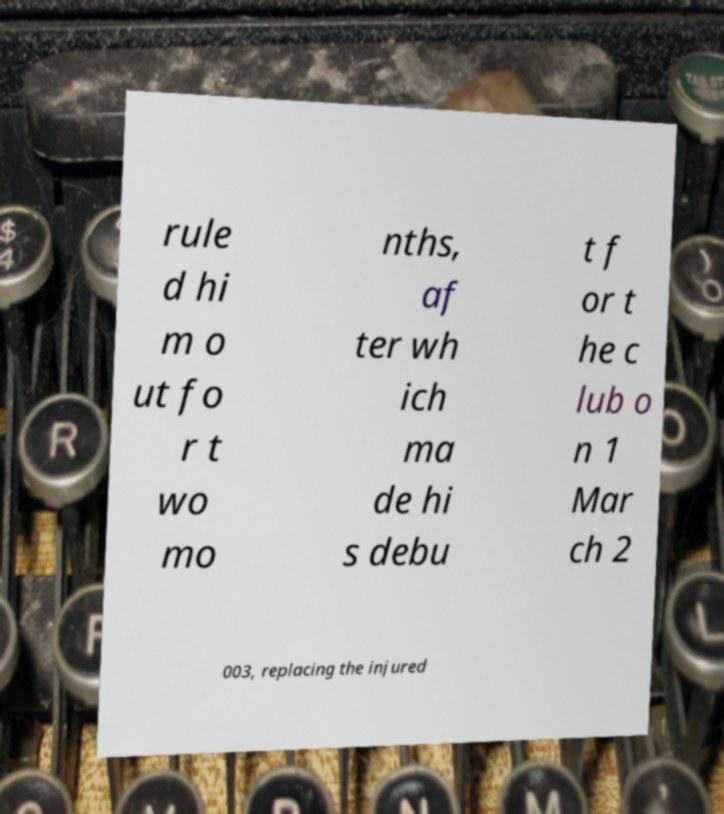For documentation purposes, I need the text within this image transcribed. Could you provide that? rule d hi m o ut fo r t wo mo nths, af ter wh ich ma de hi s debu t f or t he c lub o n 1 Mar ch 2 003, replacing the injured 